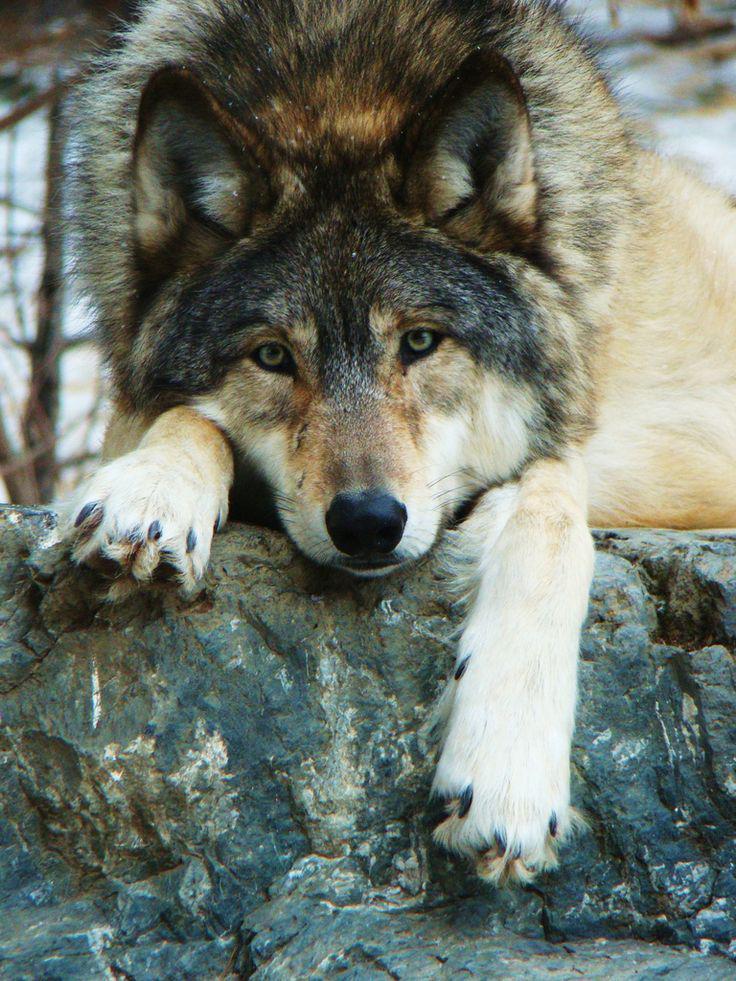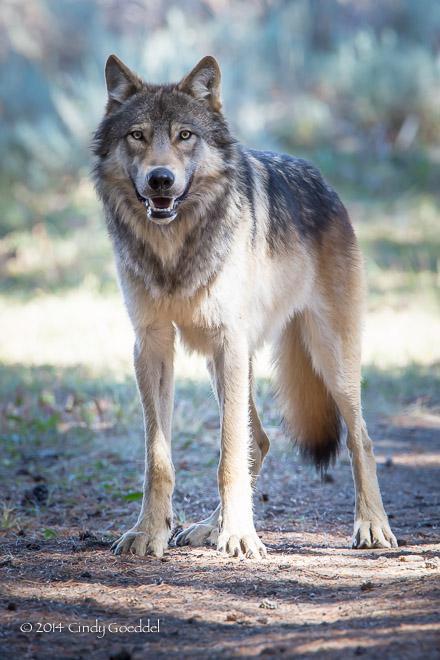The first image is the image on the left, the second image is the image on the right. Analyze the images presented: Is the assertion "The animal in the image on the right is looking toward the camera" valid? Answer yes or no. Yes. The first image is the image on the left, the second image is the image on the right. For the images shown, is this caption "An image shows a standing wolf facing the camera." true? Answer yes or no. Yes. 